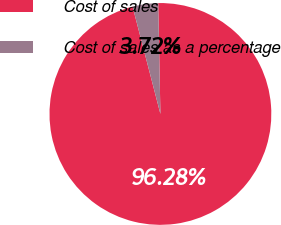Convert chart. <chart><loc_0><loc_0><loc_500><loc_500><pie_chart><fcel>Cost of sales<fcel>Cost of sales as a percentage<nl><fcel>96.28%<fcel>3.72%<nl></chart> 